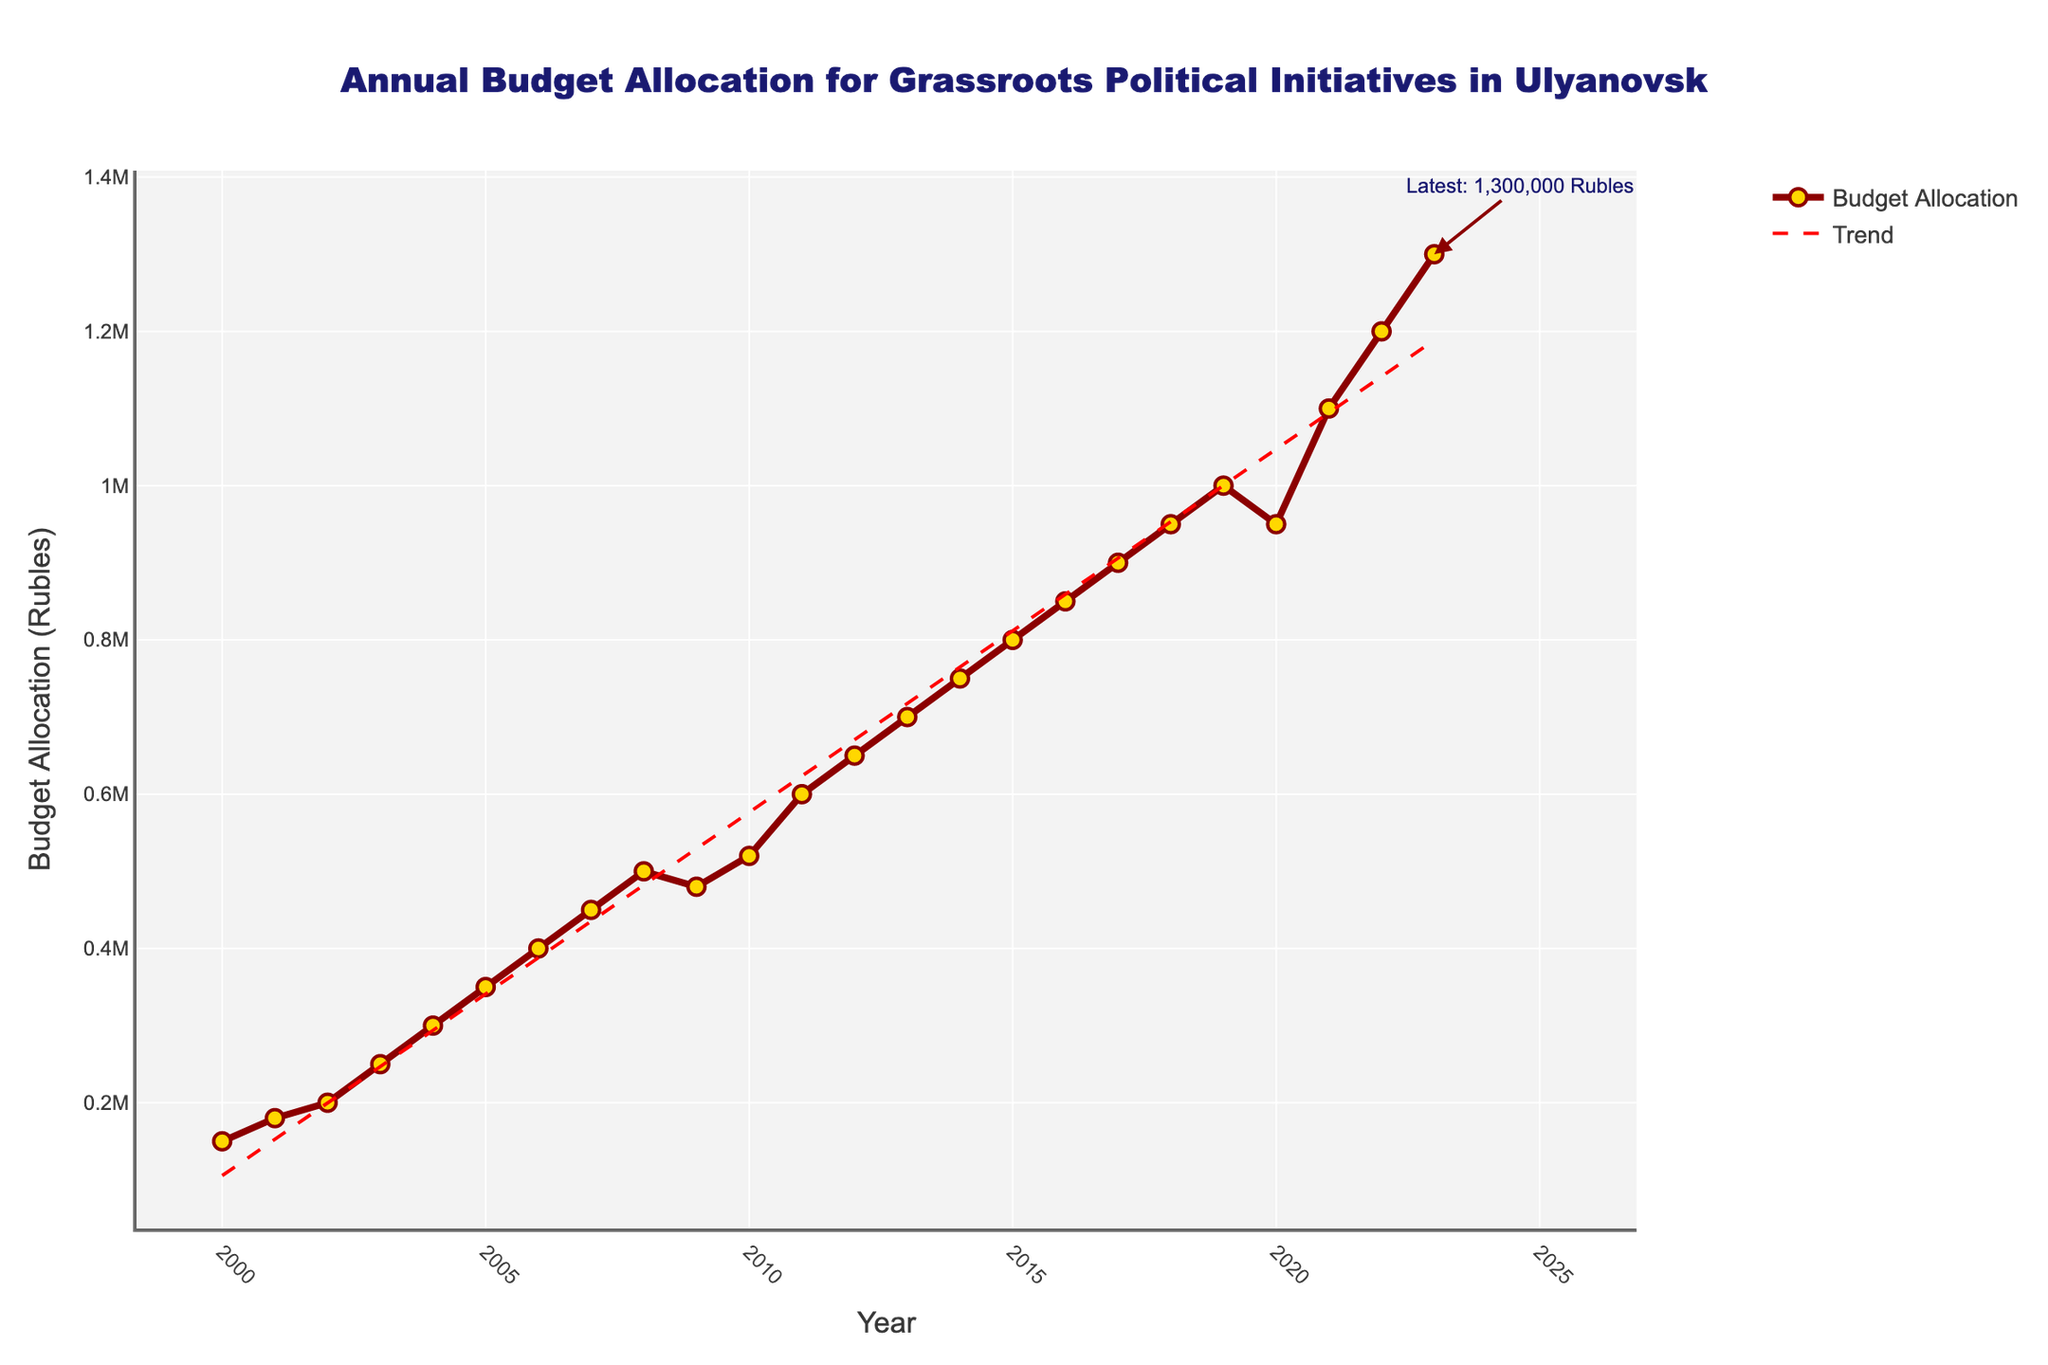What is the overall trend of the budget allocation from 2000 to 2023? The overall trend can be assessed by observing the red dashed line representing the trend line in the chart. This line shows the general direction of the budget allocation over the years. An upward or downward slope indicates an increasing or decreasing trend, respectively. From the chart, the trend line slopes upward, indicating an increasing trend in budget allocation.
Answer: Increasing Which year experienced the highest budget allocation? To identify the year with the highest budget allocation, look at the peak point in the plotted line. The highest point on the chart corresponds to 2023 with a budget allocation of 1,300,000 rubles.
Answer: 2023 How did the budget allocation change between 2019 and 2020? To determine this, compare the budget allocation values for 2019 and 2020. In 2019, it was 1,000,000 rubles, and in 2020, it decreased to 950,000 rubles. The difference can be computed as 1,000,000 - 950,000 = 50,000 rubles, indicating a decrease.
Answer: Decreased by 50,000 rubles What is the average budget allocation for the years 2000 to 2023? The average budget allocation can be found by summing all the yearly allocations from 2000 to 2023 and then dividing by the number of years (24). (150000+180000+200000+250000+300000+350000+400000+450000+500000+480000+520000+600000+650000+700000+750000+800000+850000+900000+950000+1000000+950000+1100000+1200000+1300000) / 24 = 679,583.33 rubles.
Answer: 679,583.33 rubles Which years experienced a decrease in budget allocation compared to the previous year? By observing the chart for dips in the budget allocation line from one year to the next, we can identify the years of decrease. Drops are visible between 2008-2009 and 2019-2020, where the budget allocation decreased from 500,000 to 480,000 rubles and from 1,000,000 to 950,000 rubles, respectively.
Answer: 2009 and 2020 Describe the visual appearance and attributes of the budget allocation data points and line. The budget allocation is represented by a line with markers, where the line is dark red and the markers are golden yellow circles outlined in dark red. The line connects these markers, showing an increasing trend across the years. There is also a red dashed line representing the trend line.
Answer: Dark red line with golden yellow circle markers outlined in dark red, and a red dashed trend line Compare the budget allocations in 2005 and 2012. Which year had a higher allocation, and by how much? By comparing the values for 2005 and 2012 from the chart, we see that in 2005 it was 350,000 rubles, and in 2012 it was 650,000 rubles. The difference is 650,000 - 350,000 = 300,000 rubles.
Answer: 2012 by 300,000 rubles What does the annotation in the chart indicate? The annotation in the chart is a text box pointing to the year 2023 which indicates the latest budget allocation value, stating "Latest: 1,300,000 Rubles". It highlights the current state of the budget allocation as of the latest year.
Answer: Latest budget allocation is 1,300,000 rubles 